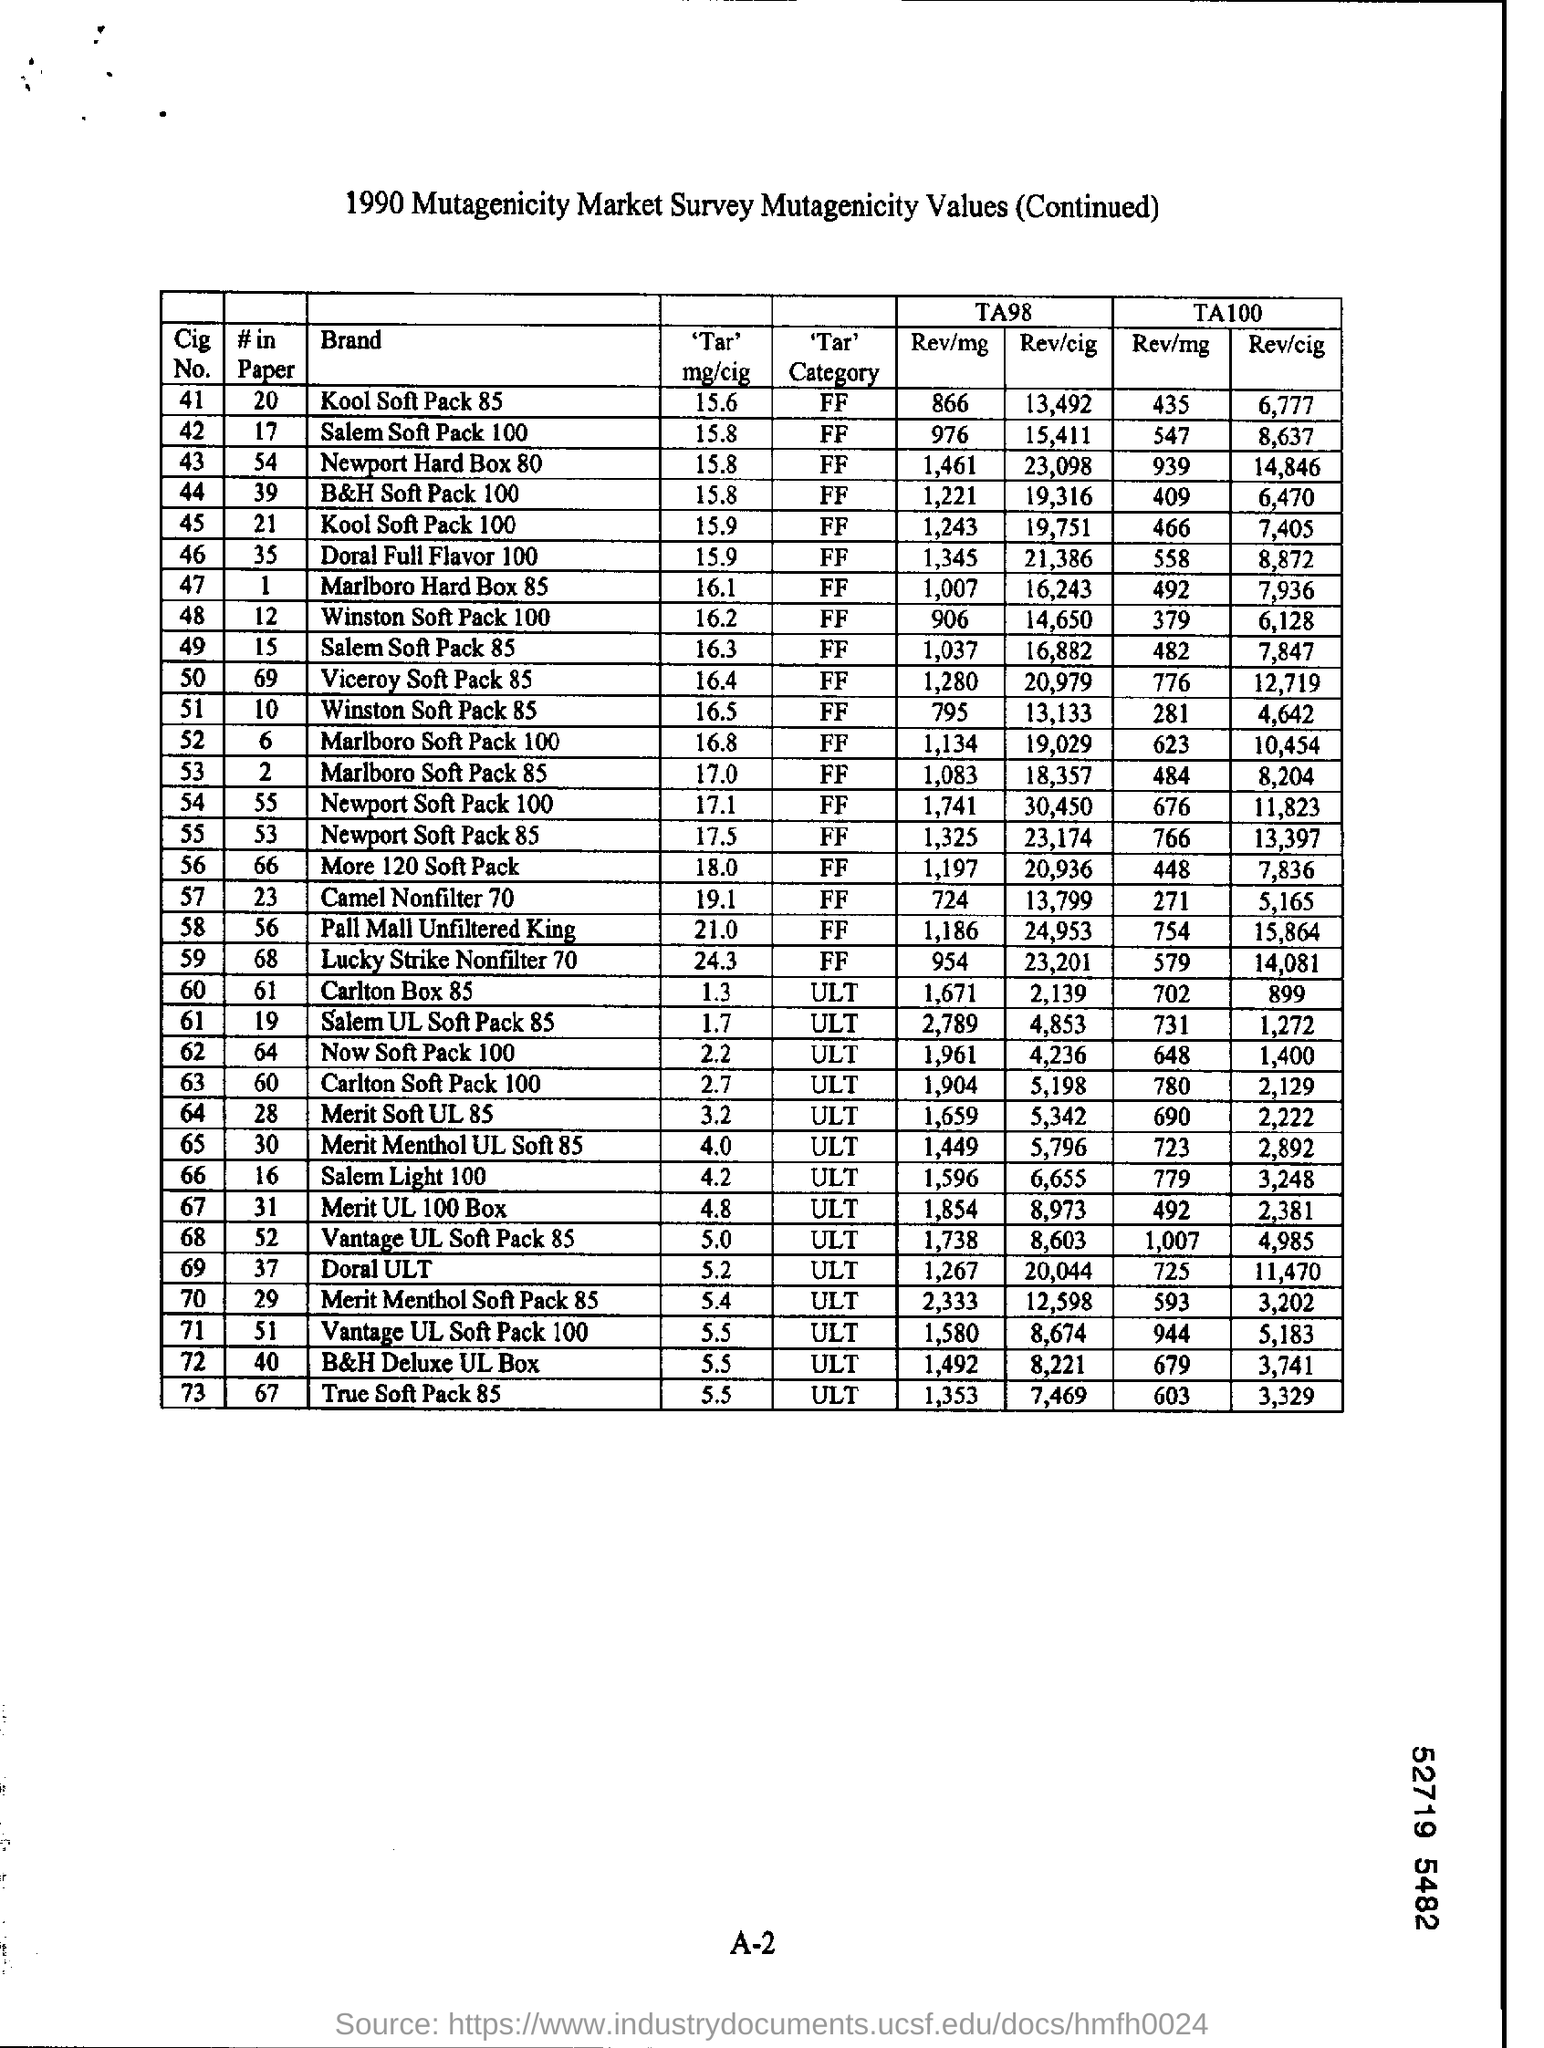How much is the #in paper for cig no. 41?
Offer a very short reply. 20. 